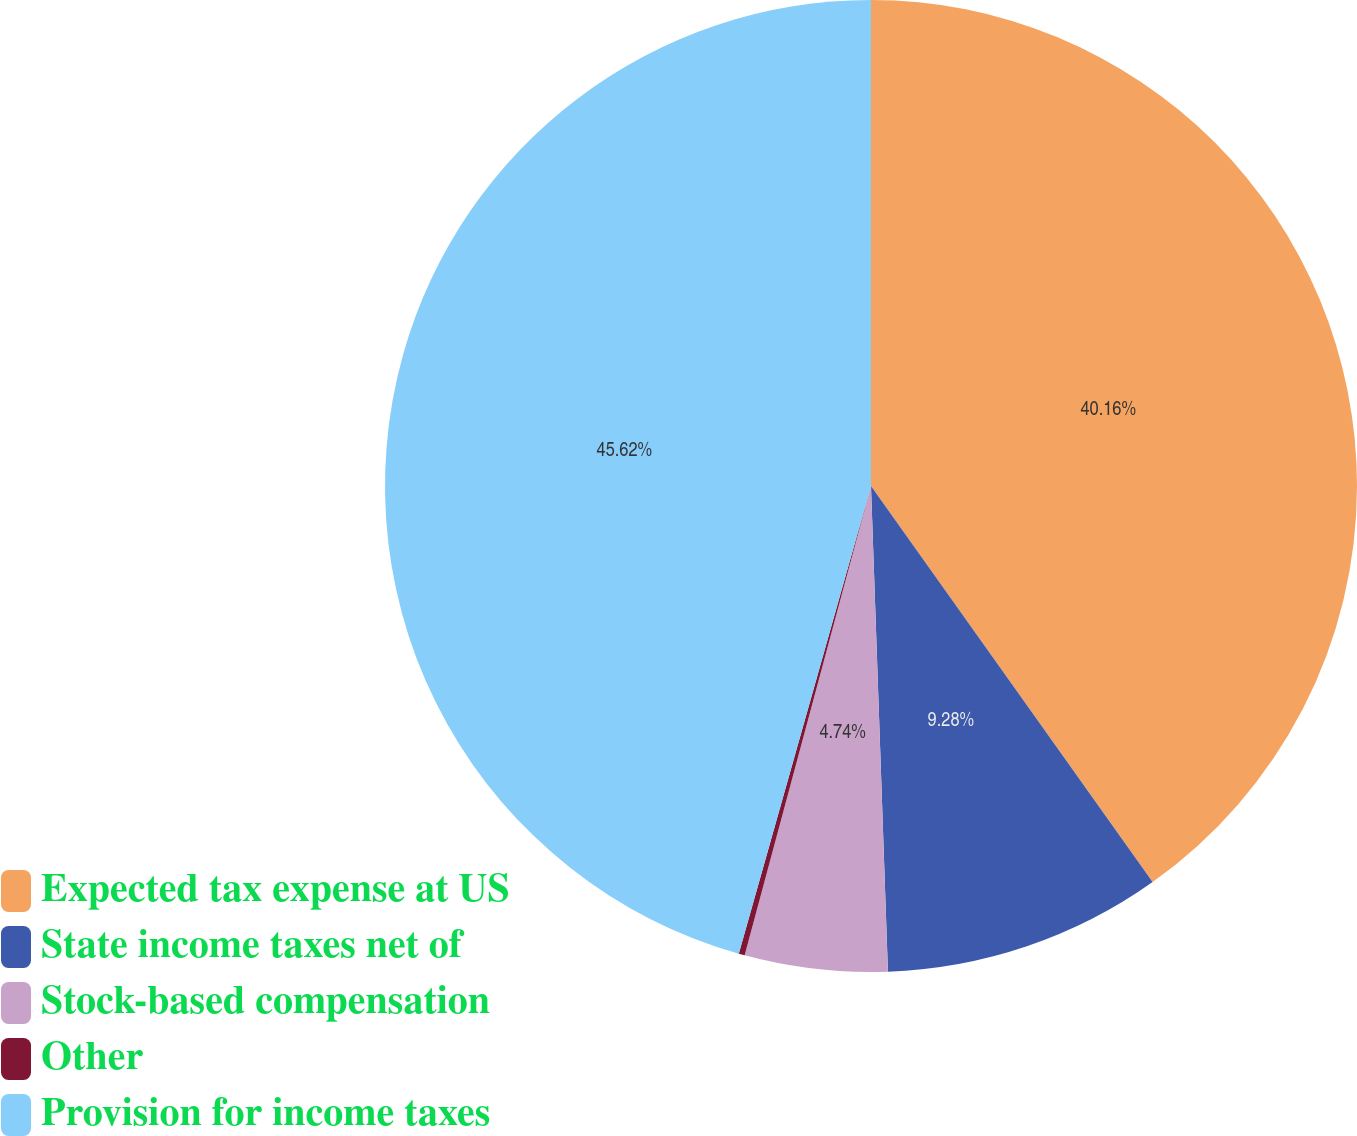<chart> <loc_0><loc_0><loc_500><loc_500><pie_chart><fcel>Expected tax expense at US<fcel>State income taxes net of<fcel>Stock-based compensation<fcel>Other<fcel>Provision for income taxes<nl><fcel>40.16%<fcel>9.28%<fcel>4.74%<fcel>0.2%<fcel>45.61%<nl></chart> 